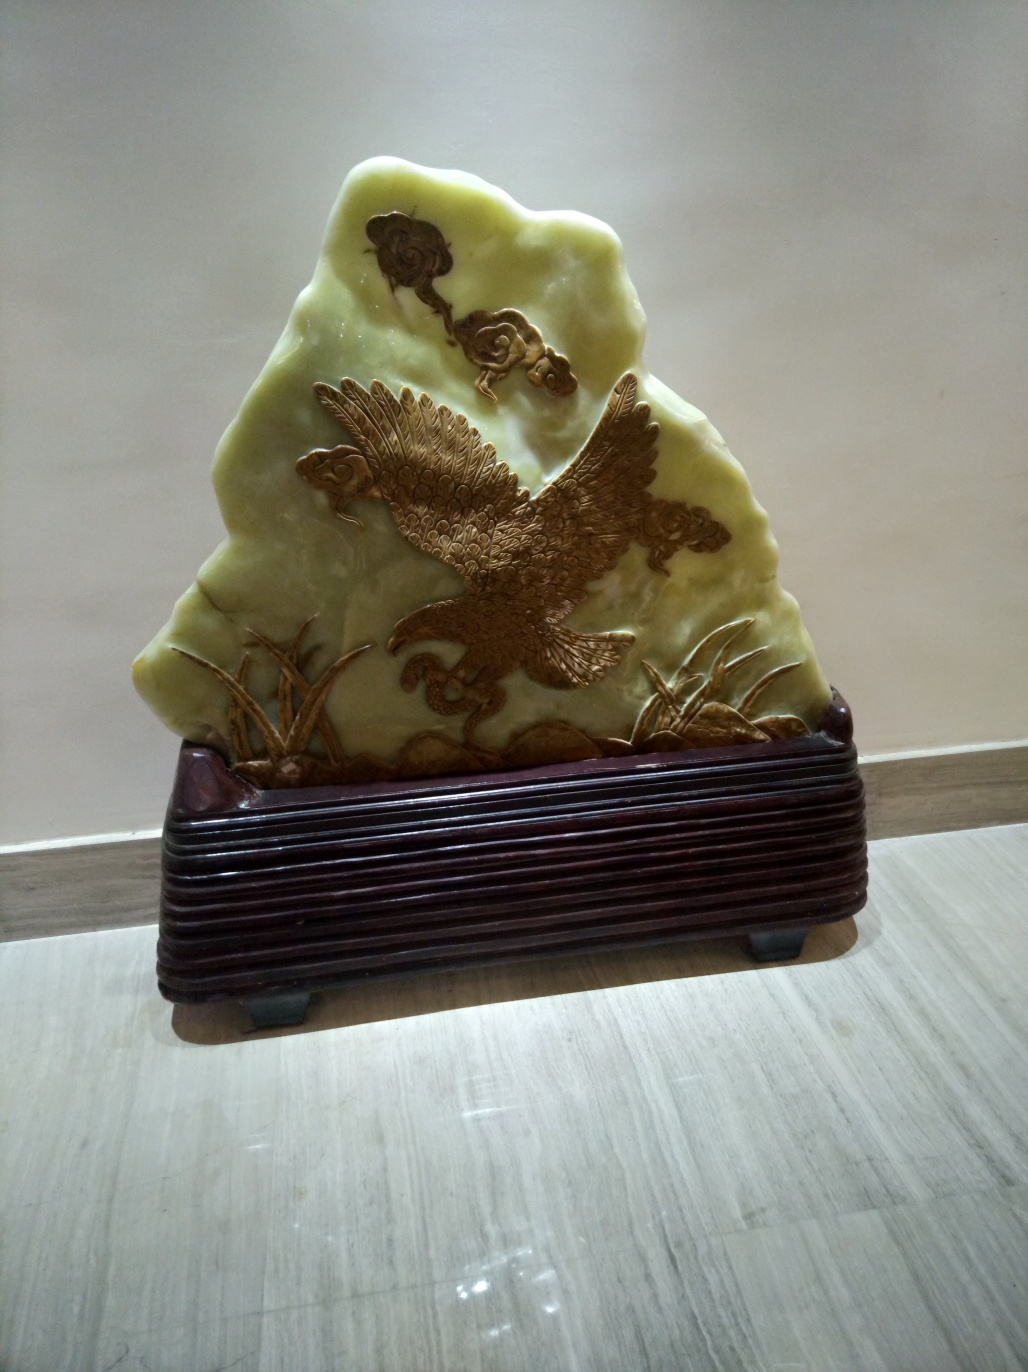How is the lighting in the image?
A. Perfect.
B. Harsh.
C. A bit weak. The lighting in the image appears to be a bit weak, as indicated by the shadows and the lack of strong highlights on the object. The soft illumination fails to accentuate the intricacies of the carving deeply, suggesting that a stronger light source could potentially enhance the visibility of the fine details. 